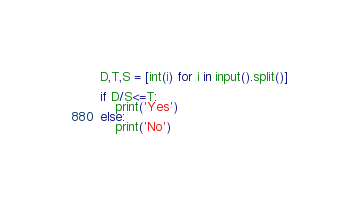Convert code to text. <code><loc_0><loc_0><loc_500><loc_500><_Python_>D,T,S = [int(i) for i in input().split()]

if D/S<=T:
    print('Yes')
else:
    print('No')
</code> 